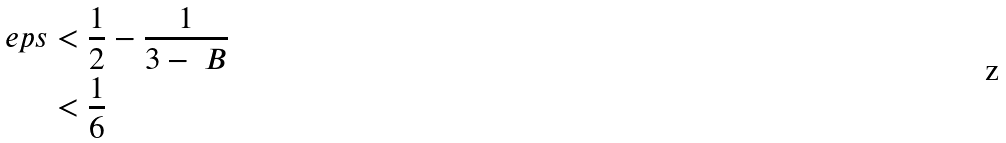<formula> <loc_0><loc_0><loc_500><loc_500>\ e p s & < \frac { 1 } { 2 } - \frac { 1 } { 3 - \ B } \\ & < \frac { 1 } { 6 }</formula> 